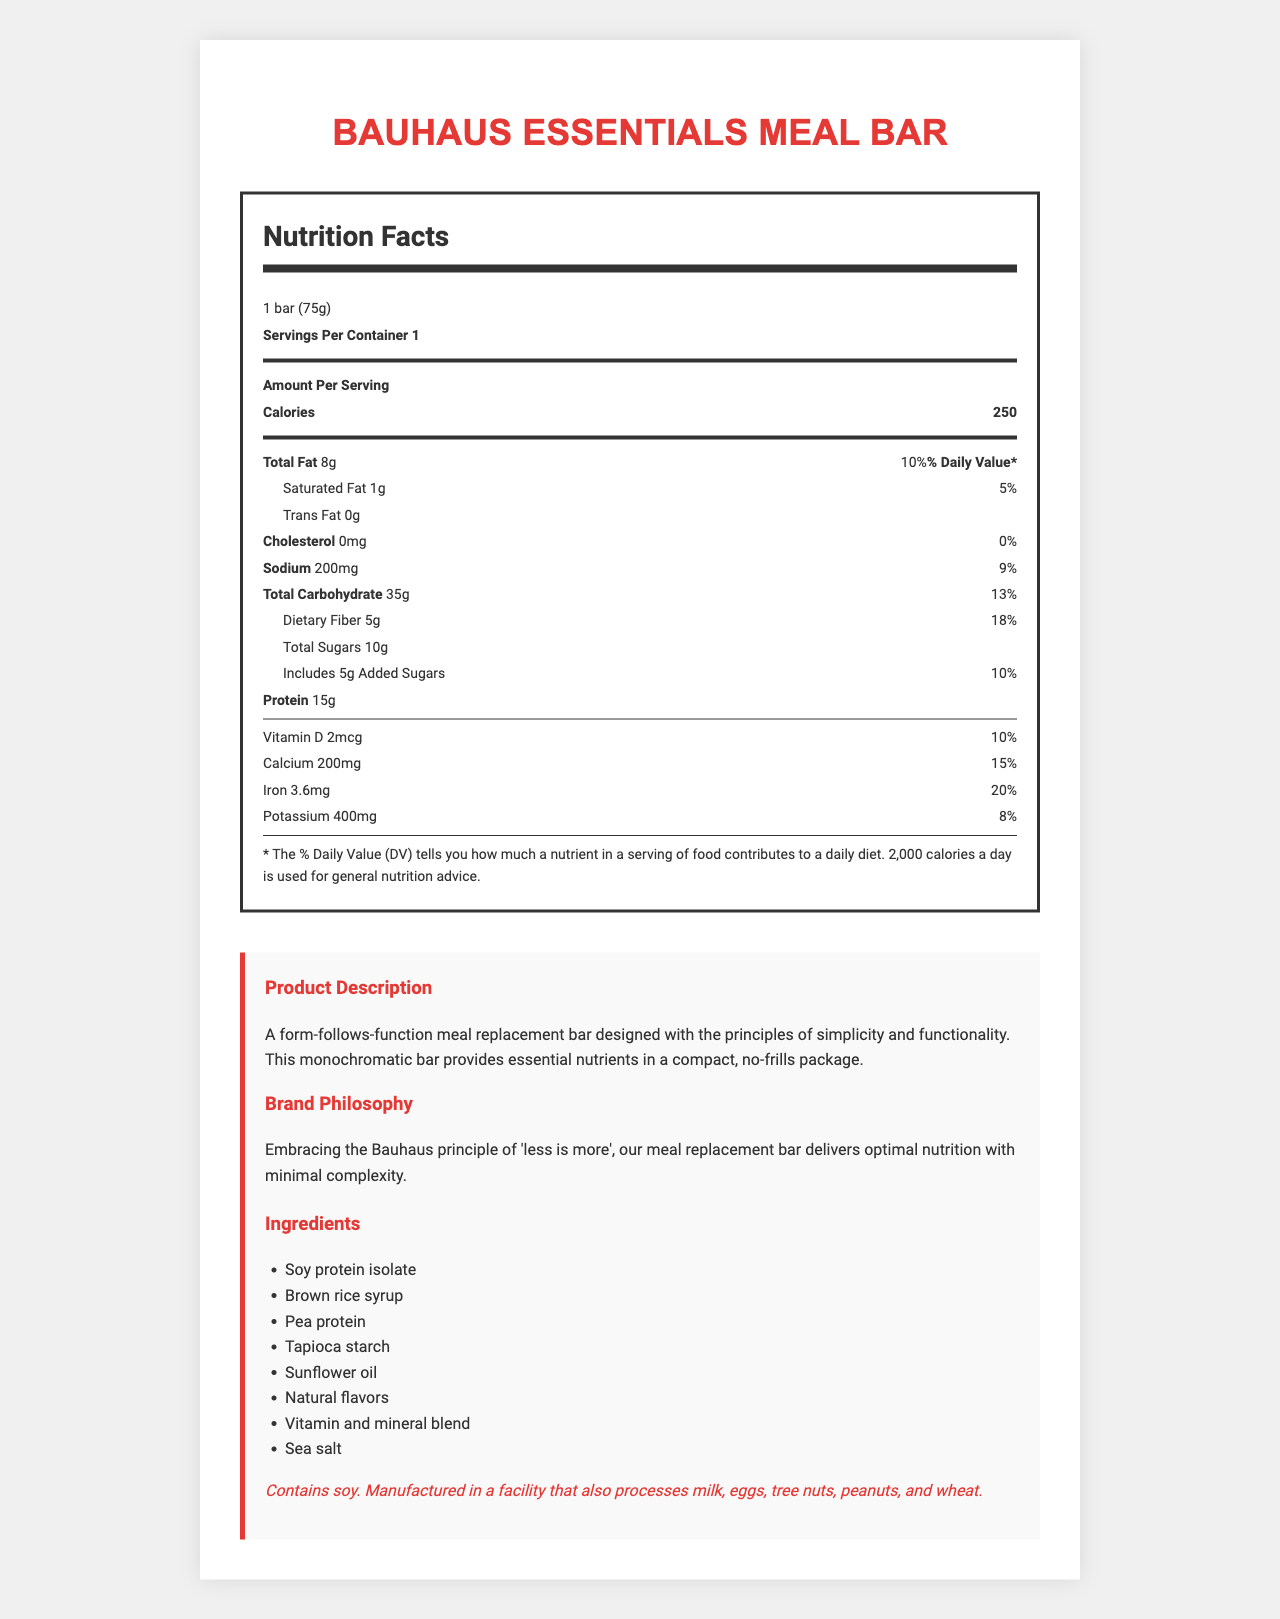what is the serving size of the Bauhaus Essentials Meal Bar? The serving size is prominently listed at the top of the Nutrition Facts section as "1 bar (75g)".
Answer: 1 bar (75g) how many grams of total fat are in a serving? The document shows "Total Fat: 8g" along with the daily value percentage.
Answer: 8g what is the amount of protein per serving? The amount of protein is listed in the Nutrition Facts section as "Protein: 15g".
Answer: 15g what percentage of the daily value of calcium does one bar provide? The daily value percentage for calcium is mentioned as "Calcium: 200mg 15%".
Answer: 15% name two ingredients listed in the meal bar. The ingredients section lists multiple ingredients, including "Soy protein isolate" and "Brown rice syrup".
Answer: Soy protein isolate, Brown rice syrup how many added sugars are included? The document mentions "Includes 5g Added Sugars".
Answer: 5g what is the design style of the packaging? The packaging is described in the product_info section.
Answer: Minimalist white wrapper with black Bauhaus-inspired geometric design does the meal bar contain any trans fats? The document states "Trans Fat 0g".
Answer: No what is the brand philosophy? This is listed in the Brand Philosophy section.
Answer: Embracing the Bauhaus principle of 'less is more', our meal replacement bar delivers optimal nutrition with minimal complexity. how much iron does one serving provide in terms of the daily value? A. 10% B. 15% C. 20% D. 25% The daily value percentage for iron is listed as "Iron: 3.6mg 20%".
Answer: C. 20% which of the following vitamins are included in the meal bar? I. Vitamin A II. Vitamin B6 III. Vitamin K IV. Vitamin E (Select all that apply) The document lists all these vitamins and their respective amounts and daily values.
Answer: I, II, III, IV (All of them are included) is this product suitable for someone with a soy allergy? The allergen_info section mentions "Contains soy."
Answer: No summarize the nutrition profile and brand philosophy of the Bauhaus Essentials Meal Bar. This description captures the nutrient contents and the brand's minimalist design philosophy.
Answer: The Bauhaus Essentials Meal Bar provides a balanced nutrition profile with 250 calories, 8g of total fat, 15g of protein, and various vitamins and minerals, while embodying the Bauhaus principle of 'less is more'. what is the manufacturing process for the bar? The document does not provide information about the manufacturing process.
Answer: Cannot be determined 